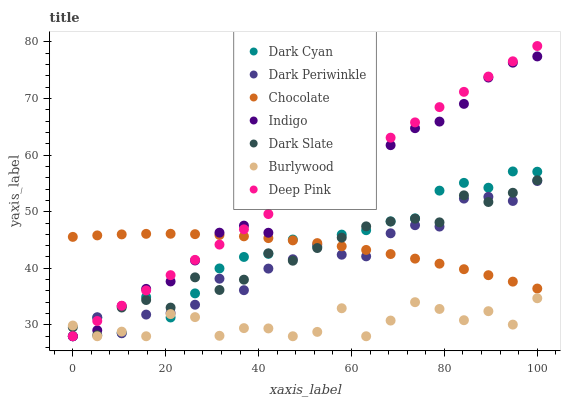Does Burlywood have the minimum area under the curve?
Answer yes or no. Yes. Does Deep Pink have the maximum area under the curve?
Answer yes or no. Yes. Does Indigo have the minimum area under the curve?
Answer yes or no. No. Does Indigo have the maximum area under the curve?
Answer yes or no. No. Is Deep Pink the smoothest?
Answer yes or no. Yes. Is Burlywood the roughest?
Answer yes or no. Yes. Is Indigo the smoothest?
Answer yes or no. No. Is Indigo the roughest?
Answer yes or no. No. Does Deep Pink have the lowest value?
Answer yes or no. Yes. Does Chocolate have the lowest value?
Answer yes or no. No. Does Deep Pink have the highest value?
Answer yes or no. Yes. Does Indigo have the highest value?
Answer yes or no. No. Is Burlywood less than Chocolate?
Answer yes or no. Yes. Is Chocolate greater than Burlywood?
Answer yes or no. Yes. Does Dark Periwinkle intersect Deep Pink?
Answer yes or no. Yes. Is Dark Periwinkle less than Deep Pink?
Answer yes or no. No. Is Dark Periwinkle greater than Deep Pink?
Answer yes or no. No. Does Burlywood intersect Chocolate?
Answer yes or no. No. 